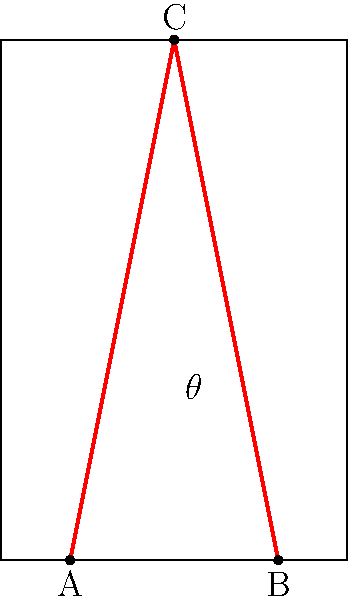In the given building design, two support structures (AC and BC) are placed to provide stability. If the height of the building is 150 units and the width is 100 units, what is the optimal angle $\theta$ between the support structures that maximizes stability while minimizing material usage? To find the optimal angle $\theta$ that maximizes stability while minimizing material usage, we need to follow these steps:

1. Recognize that the support structures form an isosceles triangle ABC.

2. The total length of the support structures is minimized when the angle $\theta$ is maximized, which occurs when the triangle is equilateral.

3. In an equilateral triangle, all angles are 60°. Therefore, the optimal angle $\theta$ should be 60°.

4. To verify, we can calculate the coordinates of point C:
   C = (50, 150)

5. Using the properties of 30-60-90 triangles:
   AC = BC = $\frac{150}{\sin 60°} = \frac{150}{\frac{\sqrt{3}}{2}} = 100\sqrt{3}$ units

6. The angle between AC and BC is indeed:
   $\angle ACB = 180° - 60° = 120°$

7. Therefore, $\theta = 120° / 2 = 60°$

This configuration provides maximum stability by distributing forces evenly while minimizing the total length of support structures.
Answer: 60° 